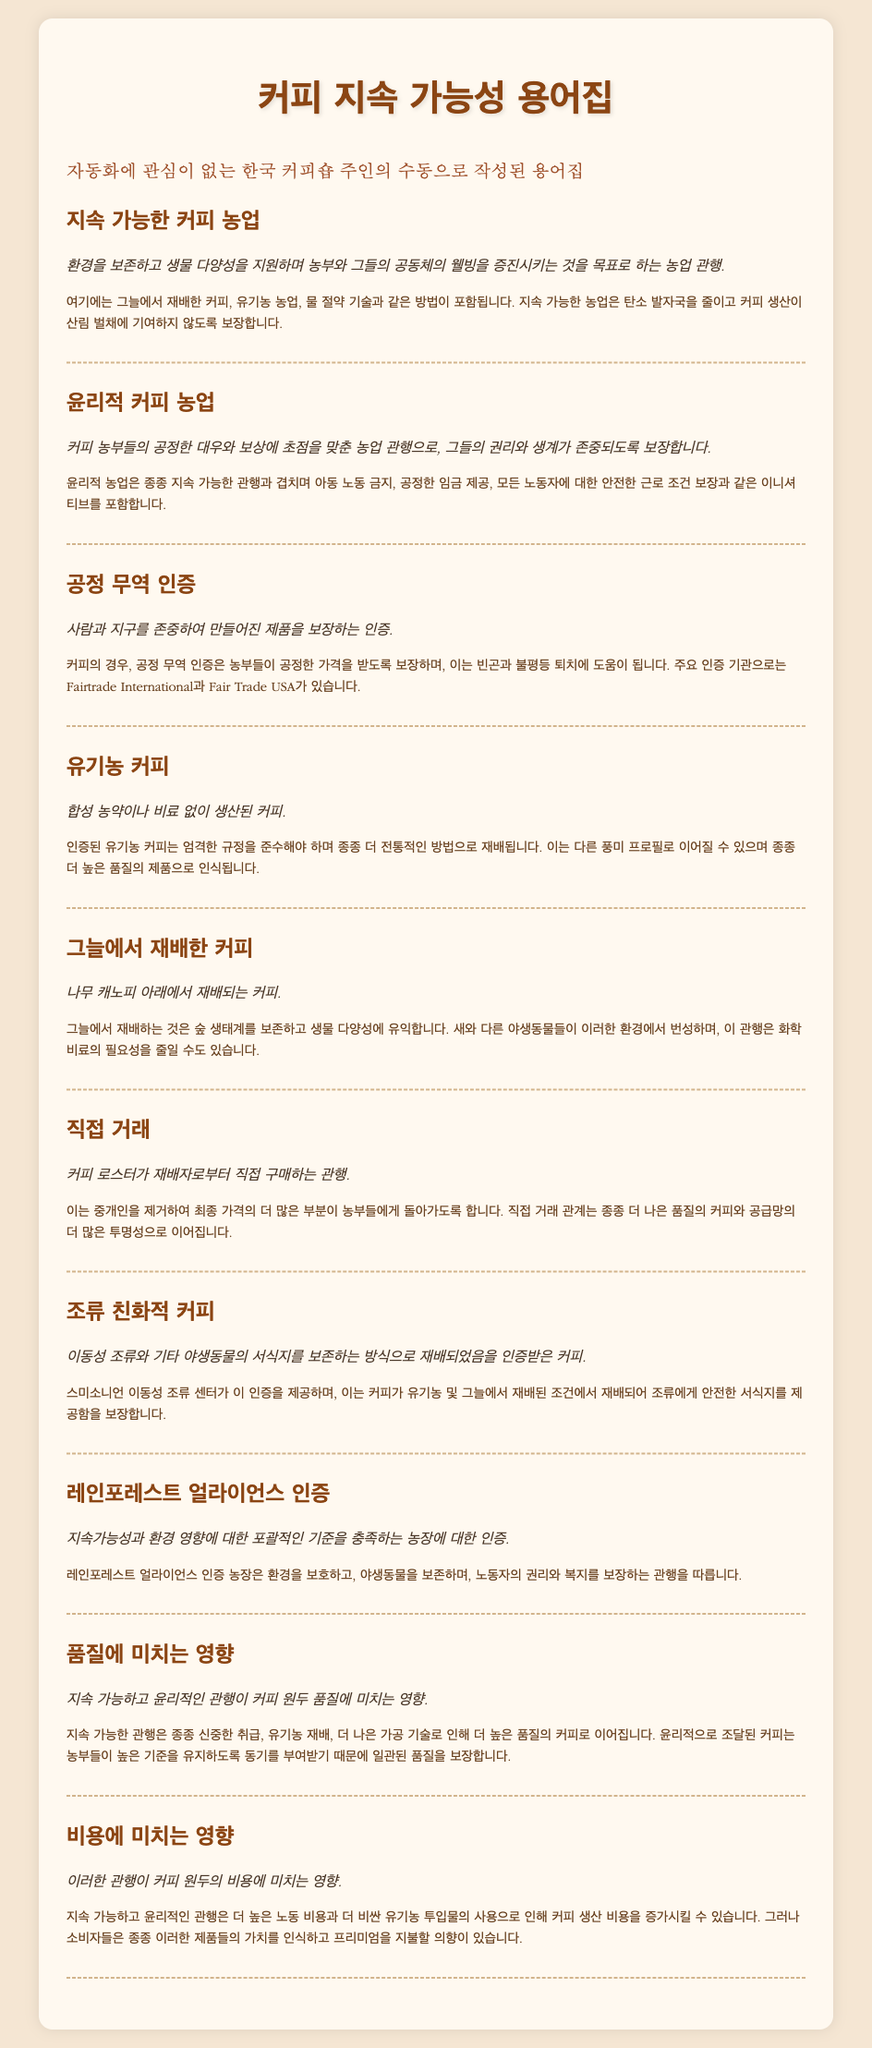what is sustainable coffee farming? Sustainable coffee farming is defined as agricultural practices aimed at preserving the environment, supporting biodiversity, and enhancing the well-being of farmers and their communities.
Answer: agricultural practices aimed at preserving the environment what is fair trade certification? Fair trade certification guarantees products made with respect for people and the planet, ensuring farmers receive fair prices.
Answer: products made with respect for people and the planet what does organic coffee mean? Organic coffee means coffee produced without synthetic pesticides or fertilizers.
Answer: without synthetic pesticides or fertilizers who provides the bird-friendly coffee certification? The Smithsonian Migratory Bird Center provides the certification for bird-friendly coffee.
Answer: Smithsonian Migratory Bird Center how do sustainable practices affect coffee quality? Sustainable practices often lead to higher quality coffee due to careful handling, organic cultivation, and better processing techniques.
Answer: higher quality coffee what is the impact of these practices on costs? Sustainable and ethical practices can increase coffee production costs due to higher labor costs and more expensive organic inputs.
Answer: increase coffee production costs what is grown under shade? Coffee grown under shade is cultivated beneath a tree canopy.
Answer: cultivated beneath a tree canopy what certification promotes environmental sustainability and worker welfare? Rainforest Alliance certification promotes comprehensive standards for environmental sustainability and worker welfare.
Answer: Rainforest Alliance certification what is the focus of ethical coffee farming? Ethical coffee farming focuses on fair treatment and compensation for coffee farmers.
Answer: fair treatment and compensation for coffee farmers 